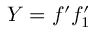Convert formula to latex. <formula><loc_0><loc_0><loc_500><loc_500>Y = f ^ { \prime } f _ { 1 } ^ { \prime }</formula> 